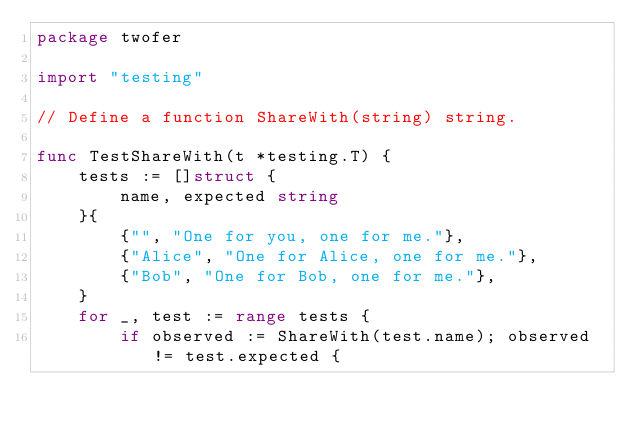Convert code to text. <code><loc_0><loc_0><loc_500><loc_500><_Go_>package twofer

import "testing"

// Define a function ShareWith(string) string.

func TestShareWith(t *testing.T) {
	tests := []struct {
		name, expected string
	}{
		{"", "One for you, one for me."},
		{"Alice", "One for Alice, one for me."},
		{"Bob", "One for Bob, one for me."},
	}
	for _, test := range tests {
		if observed := ShareWith(test.name); observed != test.expected {</code> 